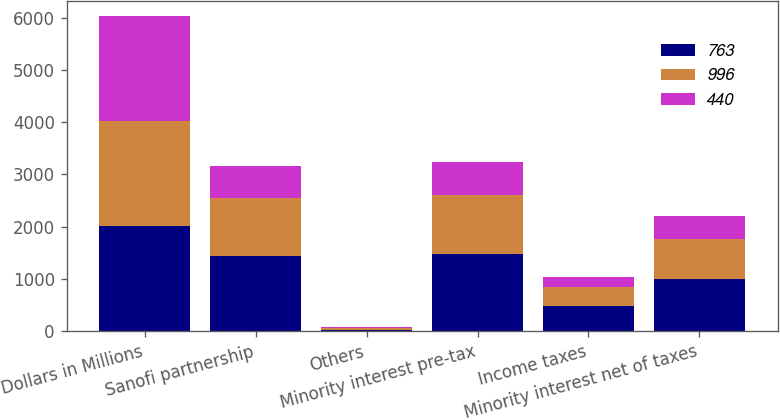<chart> <loc_0><loc_0><loc_500><loc_500><stacked_bar_chart><ecel><fcel>Dollars in Millions<fcel>Sanofi partnership<fcel>Others<fcel>Minority interest pre-tax<fcel>Income taxes<fcel>Minority interest net of taxes<nl><fcel>763<fcel>2008<fcel>1444<fcel>24<fcel>1468<fcel>472<fcel>996<nl><fcel>996<fcel>2007<fcel>1106<fcel>26<fcel>1132<fcel>369<fcel>763<nl><fcel>440<fcel>2006<fcel>609<fcel>19<fcel>628<fcel>188<fcel>440<nl></chart> 